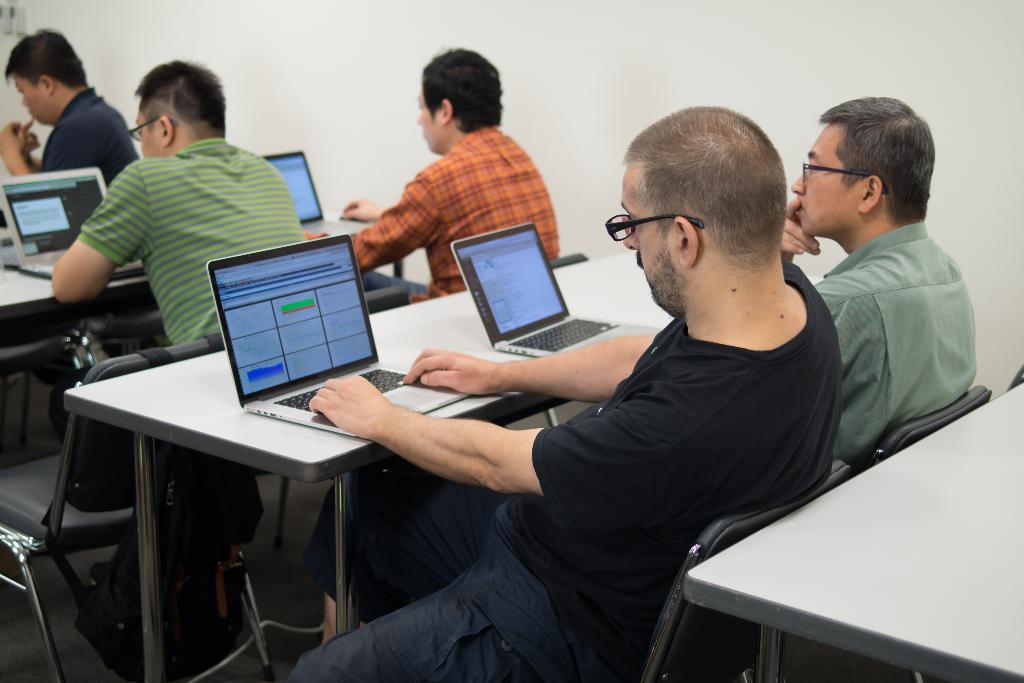How many men are in the image? There are 5 men in the image. What are the men doing in the image? The men are sitting on chairs. What objects can be seen on the tables in the image? Laptops are present on the tables. Is there any bag visible in the image? Yes, there is a bag in the image. What can be seen in the background of the image? There is a white wall in the background of the image. What type of notebook is being used by the men in the image? There is no notebook present in the image; the men are using laptops. What type of mine can be seen in the image? There is no mine present in the image; it is a group of men sitting on chairs with laptops and a bag. 